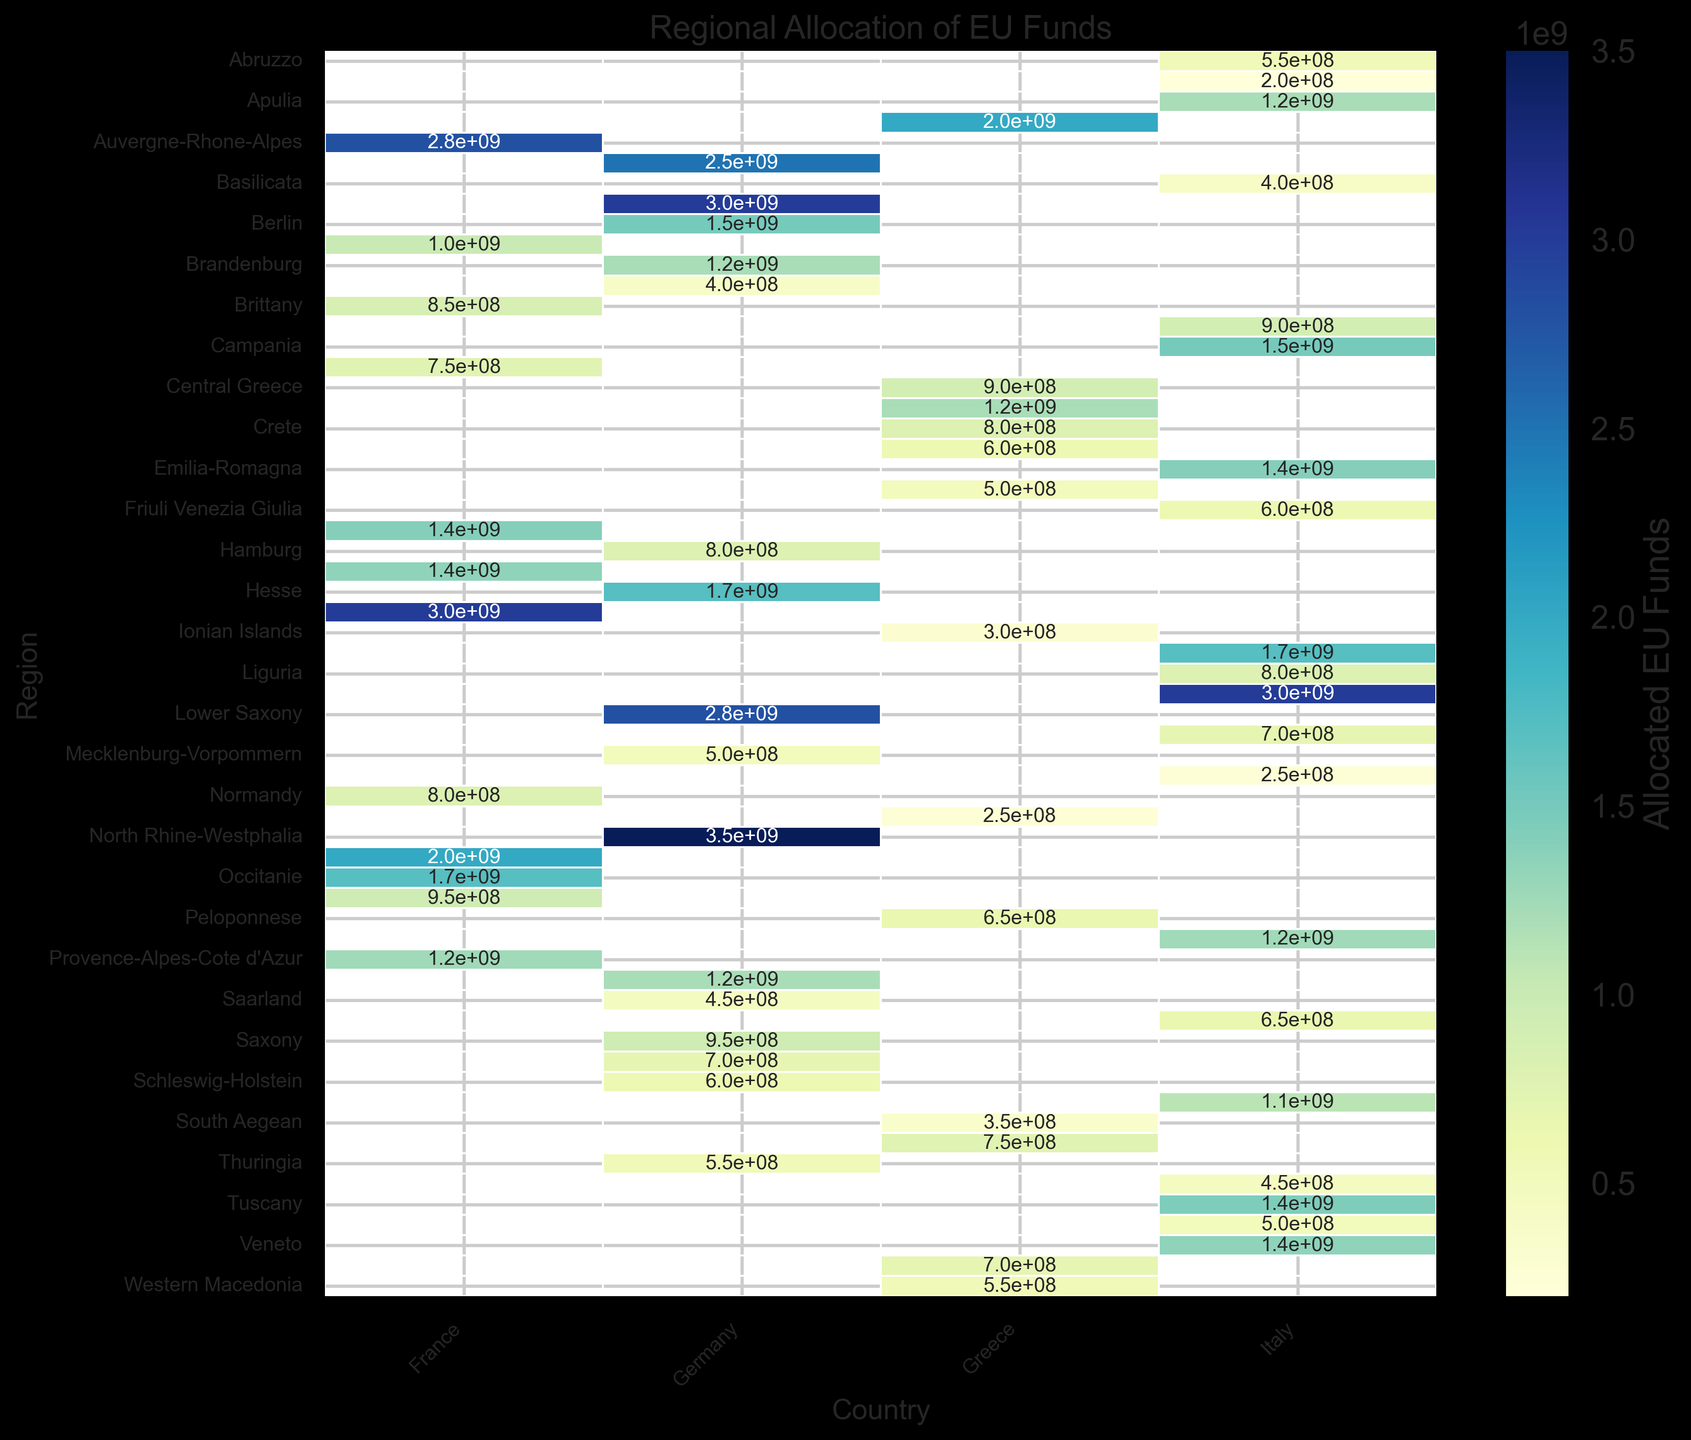Which region in Greece received the highest allocated EU funds? From the heatmap, observe the regions under "Greece" and compare the values. Attica has the highest allocation of 2,000,000,000 euros.
Answer: Attica How does the EU fund allocation for Central Macedonia in Greece compare to Thuringia in Germany? Locate both regions on the heatmap and compare the values. Central Macedonia received 1,200,000,000 euros while Thuringia received 550,000,000 euros.
Answer: Central Macedonia received more What's the total allocation of EU funds for Greece? Sum up all the values for the regions under Greece in the heatmap. (2,000,000,000 + 900,000,000 + 1,200,000,000 + 700,000,000 + 800,000,000 + 600,000,000 + 500,000,000 + 300,000,000 + 250,000,000 + 650,000,000 + 350,000,000 + 750,000,000 + 550,000,000) = 9,550,000,000 euros.
Answer: 9,550,000,000 euros Which region in Italy has the lowest EU fund allocation? From the heatmap, identify the smallest value under "Italy". Aosta Valley has the lowest with 200,000,000 euros.
Answer: Aosta Valley Are there any regions in Germany that received the same amount of EU funds as Central Greece in Greece? Compare the value for Central Greece (900,000,000 euros) with all the regions in Germany. Bavaria and Rhineland-Palatinate both have 1,200,000,000 euros, but none have exactly 900,000,000 euros.
Answer: No What is the average EU fund allocation for regions in France? Sum up all the EU fund allocations for the French regions and divide by the number of regions. (2,800,000,000 + 1,000,000,000 + 850,000,000 + 750,000,000 + 1,400,000,000 + 1,350,000,000 + 3,000,000,000 + 800,000,000 + 2,000,000,000 + 1,700,000,000 + 950,000,000 + 1,250,000,000) = 17,850,000,000. There are 12 regions, so the average is 17,850,000,000 / 12 = 1,487,500,000 euros.
Answer: 1,487,500,000 euros What is the median fund allocation for regions in Germany? List the fund allocations for regions in Germany: (2,500,000,000, 3,000,000,000, 1,500,000,000, 1,200,000,000, 400,000,000, 800,000,000, 1,700,000,000, 500,000,000, 2,800,000,000, 3,500,000,000, 1,200,000,000, 450,000,000, 950,000,000, 700,000,000, 600,000,000, 550,000,000). After sorting: (400,000,000, 450,000,000, 500,000,000, 550,000,000, 600,000,000, 700,000,000, 800,000,000, 950,000,000, 1,200,000,000, 1,200,000,000, 1,500,000,000, 1,700,000,000, 2,500,000,000, 2,800,000,000, 3,000,000,000, 3,500,000,000). The median is the average of 8th and 9th values: (950,000,000 + 1,200,000,000) / 2 = 1,075,000,000 euros.
Answer: 1,075,000,000 euros Which country has the region with the highest EU fund allocation? Locate the region with the darkest shading on the heatmap indicating the highest allocation. Germany's North Rhine-Westphalia received 3,500,000,000 euros.
Answer: Germany How does the allocation for Crete in Greece compare with Pays de la Loire in France? Find the values for both regions in the heatmap. Crete received 800,000,000 euros while Pays de la Loire received 950,000,000 euros.
Answer: Pays de la Loire received more What is the range of the allocated EU funds for Italian regions? Identify the smallest and largest fund allocations in Italy. The smallest is Aosta Valley with 200,000,000 euros and the largest is Lombardy with 3,000,000,000 euros. The range is 3,000,000,000 - 200,000,000 = 2,800,000,000 euros.
Answer: 2,800,000,000 euros 